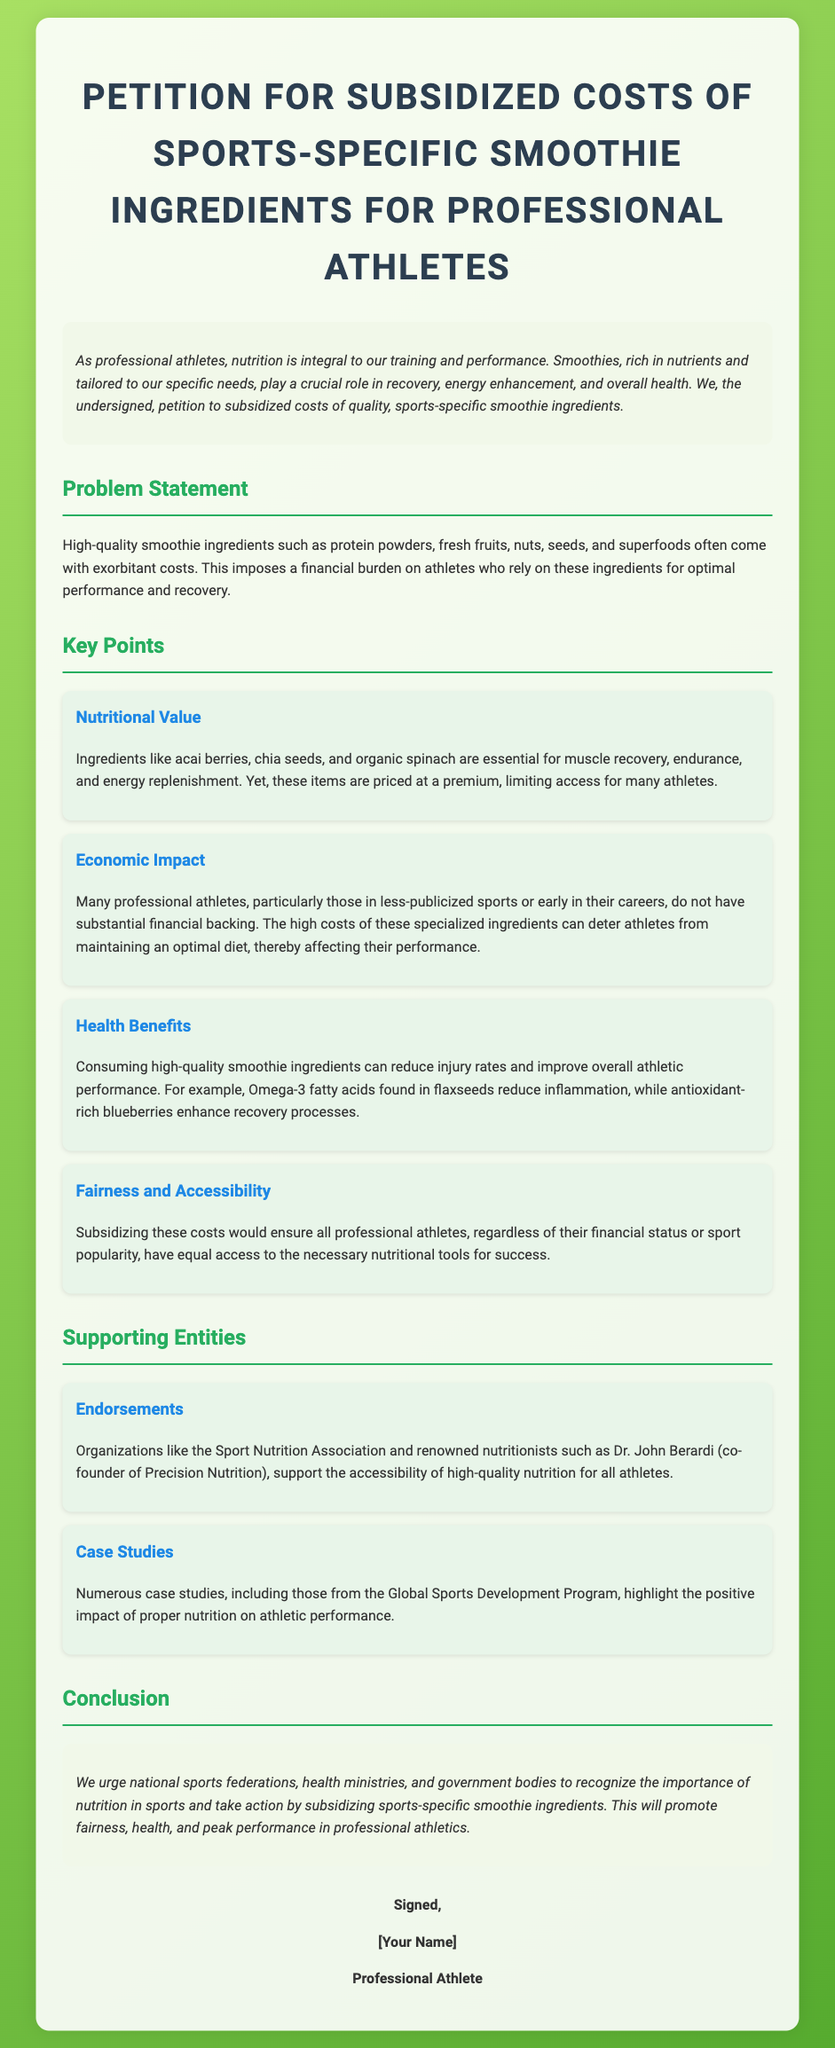what is the title of the petition? The title of the petition is stated at the top of the document and encapsulates its purpose.
Answer: Petition for Subsidized Costs of Sports-Specific Smoothie Ingredients for Professional Athletes how does the introduction describe smoothies? The introduction outlines the importance of smoothies in the athletes' nutrition and training regimens.
Answer: Integral to training and performance what are considered high-quality smoothie ingredients? The document explicitly mentions specific ingredients that fall under this category, pointing to their significance for athletes.
Answer: Protein powders, fresh fruits, nuts, seeds, and superfoods what is one of the nutritional values mentioned? The document provides examples of ingredients that offer nutritional benefits to athletes.
Answer: Acai berries which organization supports the petition's goals? The petition includes endorsements from notable entities or associations supporting the cause.
Answer: Sport Nutrition Association what is a key reason for subsidizing smoothie ingredients? The document highlights the importance of equitable access to necessary nutrition for all athletes, tying it to overall performance and fairness.
Answer: Fairness and Accessibility how do high-quality ingredients impact injury rates? It is stated in the document how nutrition affects injury rates and performance levels for athletes.
Answer: Reduce injury rates how many key points are outlined in the document? The number of key points is directly listed in the document under the section pertaining to these points.
Answer: Four what is the conclusion urging national bodies to do? The conclusion summarizes the action that the authors of the petition want governing bodies to take concerning the issue raised.
Answer: Subsidize sports-specific smoothie ingredients 